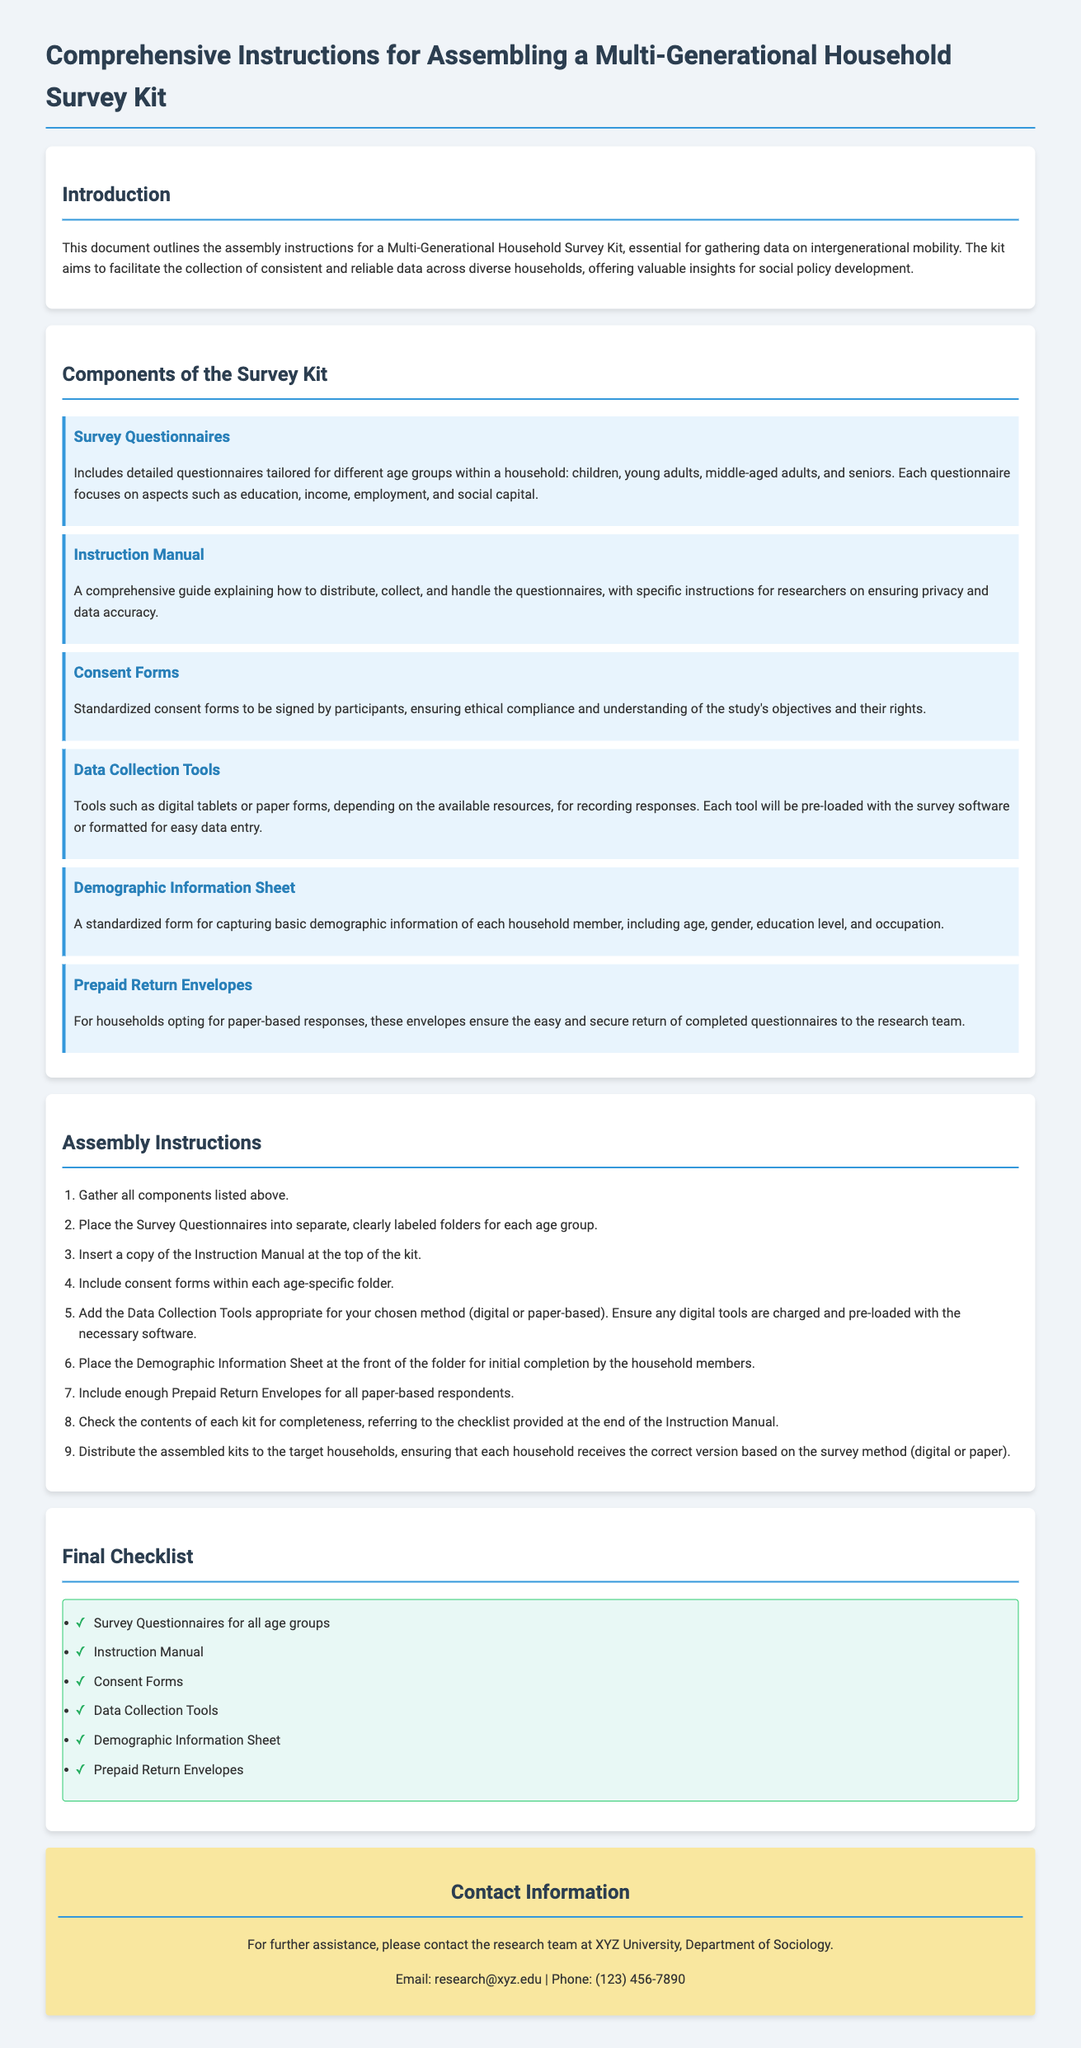What is the title of the document? The title is found at the beginning of the document, indicating the content.
Answer: Comprehensive Instructions for Assembling a Multi-Generational Household Survey Kit How many components are listed in the Survey Kit? The number of components is detailed in the section about the components of the kit.
Answer: Six What is one component of the Survey Kit? The components of the Survey Kit are specifically listed in the document.
Answer: Survey Questionnaires What should be placed on top of the kit? The document states that the instruction manual should be placed at the top of the kit.
Answer: Instruction Manual What is the purpose of consent forms? The document outlines the purpose of consent forms in terms of ethical compliance.
Answer: Ensuring ethical compliance What is the first step in the assembly instructions? The assembly instructions begin with gathering all components.
Answer: Gather all components listed above How many items are in the final checklist? The final checklist enumerates the essential items to include in the kit.
Answer: Six What kind of tools are mentioned for data collection? The document specifies the types of tools used for data collection.
Answer: Digital tablets or paper forms Where should you check for completeness of the kit? The document suggests referring to the checklist provided at the end to ensure completeness.
Answer: Checklist provided at the end of the Instruction Manual 